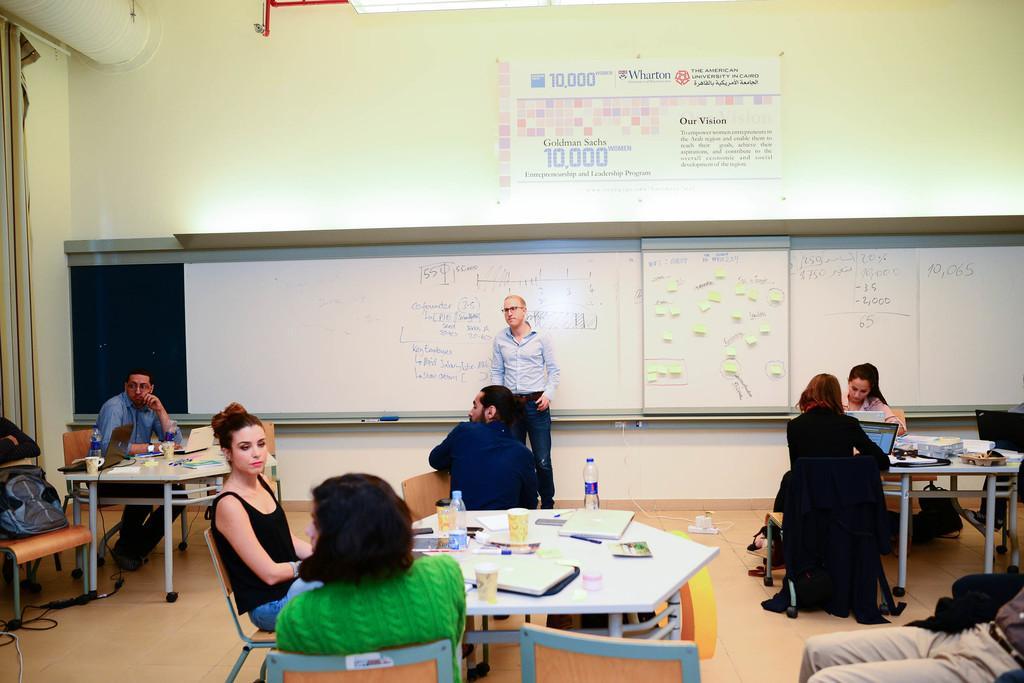Could you give a brief overview of what you see in this image? It is a room there are lot of tables and some people are sitting around the tables, on the tables there are books,pens and bottles in the background there is a person standing and behind them there is a whiteboard above it there is a projector and there is a wall of cream color. 